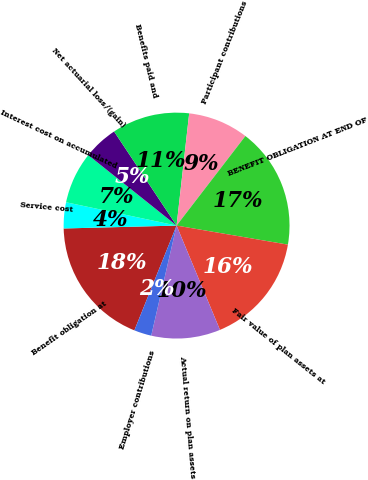Convert chart. <chart><loc_0><loc_0><loc_500><loc_500><pie_chart><fcel>Benefit obligation at<fcel>Service cost<fcel>Interest cost on accumulated<fcel>Net actuarial loss/(gain)<fcel>Benefits paid and<fcel>Participant contributions<fcel>BENEFIT OBLIGATION AT END OF<fcel>Fair value of plan assets at<fcel>Actual return on plan assets<fcel>Employer contributions<nl><fcel>18.5%<fcel>3.72%<fcel>7.41%<fcel>4.95%<fcel>11.11%<fcel>8.65%<fcel>17.27%<fcel>16.03%<fcel>9.88%<fcel>2.49%<nl></chart> 